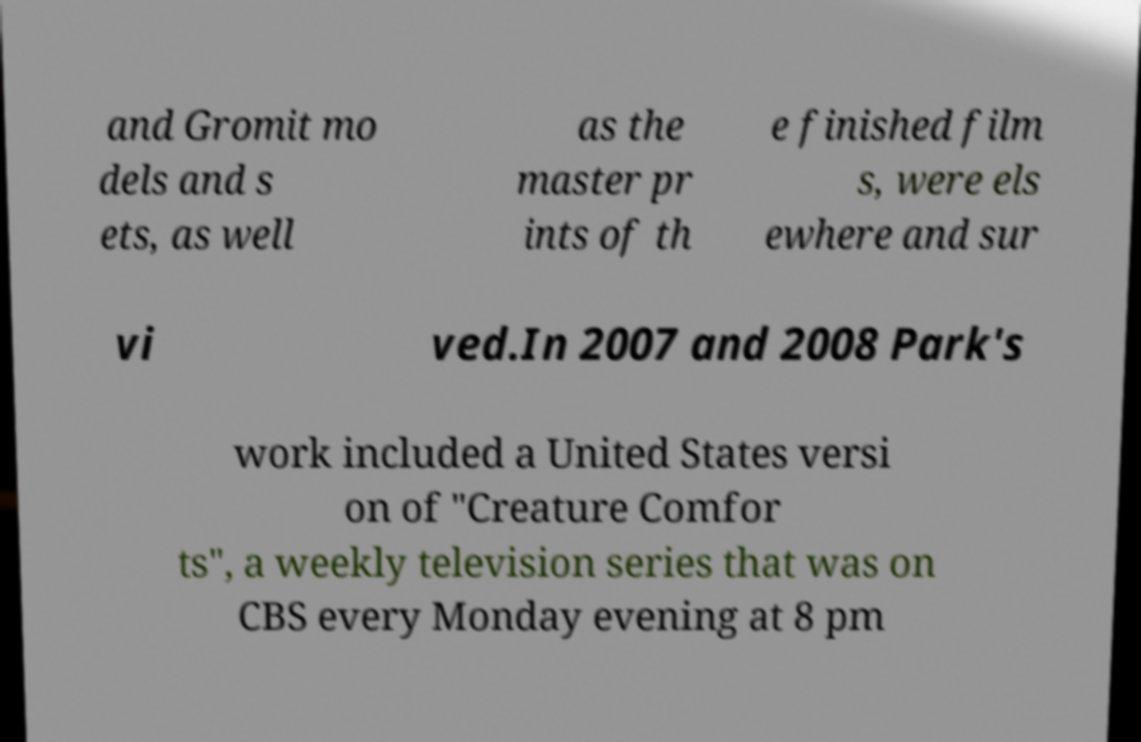What messages or text are displayed in this image? I need them in a readable, typed format. and Gromit mo dels and s ets, as well as the master pr ints of th e finished film s, were els ewhere and sur vi ved.In 2007 and 2008 Park's work included a United States versi on of "Creature Comfor ts", a weekly television series that was on CBS every Monday evening at 8 pm 